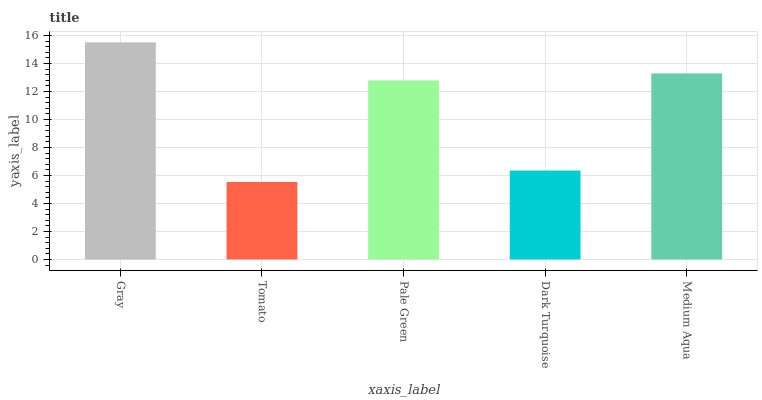Is Tomato the minimum?
Answer yes or no. Yes. Is Gray the maximum?
Answer yes or no. Yes. Is Pale Green the minimum?
Answer yes or no. No. Is Pale Green the maximum?
Answer yes or no. No. Is Pale Green greater than Tomato?
Answer yes or no. Yes. Is Tomato less than Pale Green?
Answer yes or no. Yes. Is Tomato greater than Pale Green?
Answer yes or no. No. Is Pale Green less than Tomato?
Answer yes or no. No. Is Pale Green the high median?
Answer yes or no. Yes. Is Pale Green the low median?
Answer yes or no. Yes. Is Tomato the high median?
Answer yes or no. No. Is Gray the low median?
Answer yes or no. No. 